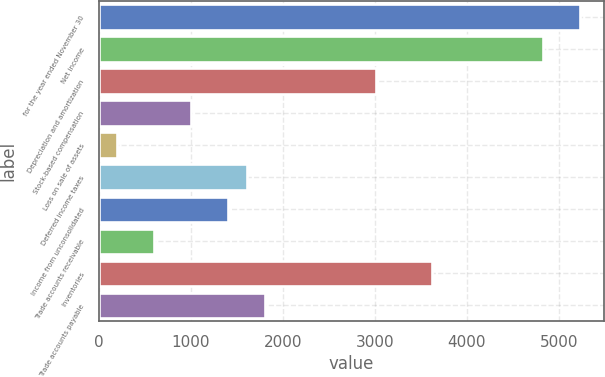<chart> <loc_0><loc_0><loc_500><loc_500><bar_chart><fcel>for the year ended November 30<fcel>Net income<fcel>Depreciation and amortization<fcel>Stock-based compensation<fcel>Loss on sale of assets<fcel>Deferred income taxes<fcel>Income from unconsolidated<fcel>Trade accounts receivable<fcel>Inventories<fcel>Trade accounts payable<nl><fcel>5227.64<fcel>4825.56<fcel>3016.2<fcel>1005.8<fcel>201.64<fcel>1608.92<fcel>1407.88<fcel>603.72<fcel>3619.32<fcel>1809.96<nl></chart> 